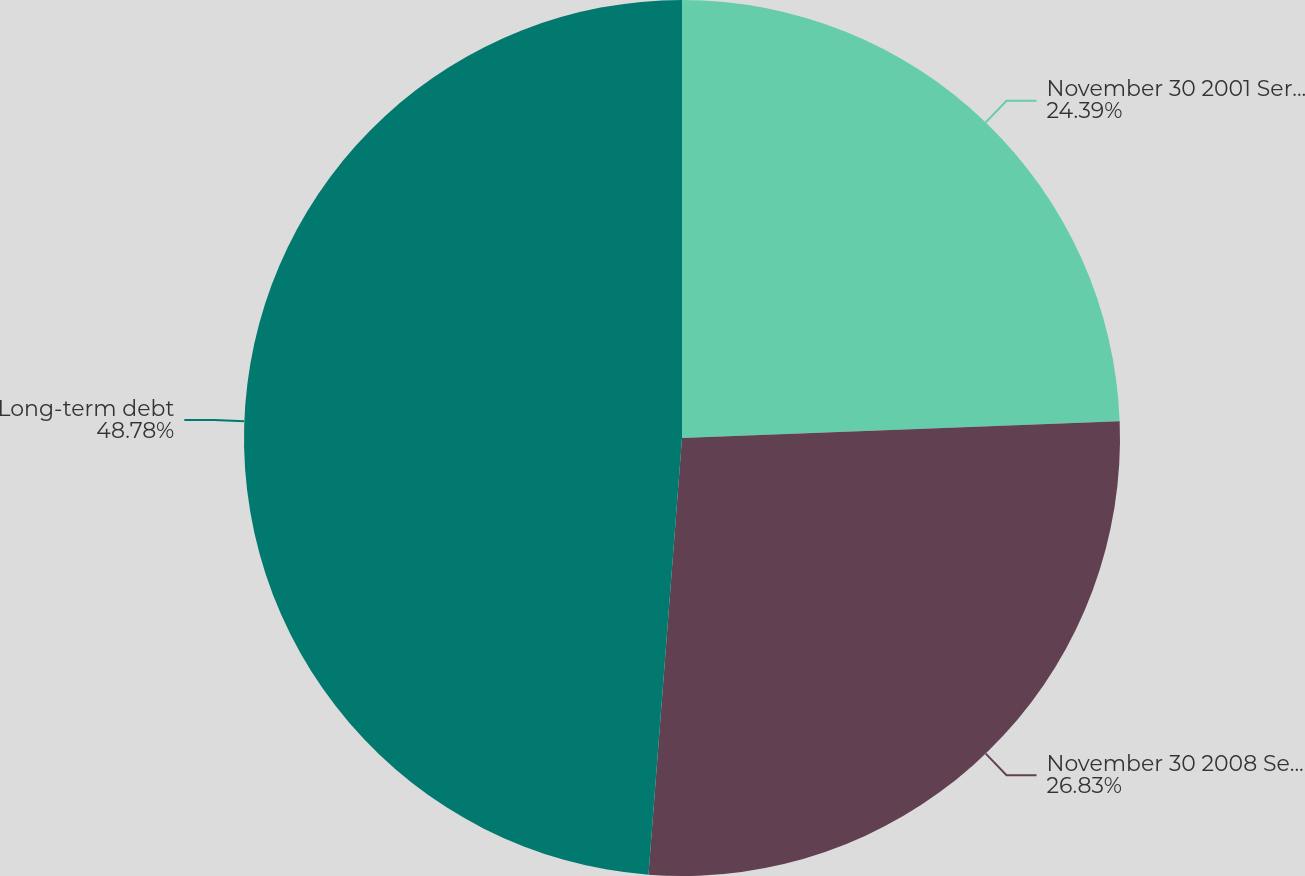<chart> <loc_0><loc_0><loc_500><loc_500><pie_chart><fcel>November 30 2001 Series B<fcel>November 30 2008 Senior<fcel>Long-term debt<nl><fcel>24.39%<fcel>26.83%<fcel>48.78%<nl></chart> 